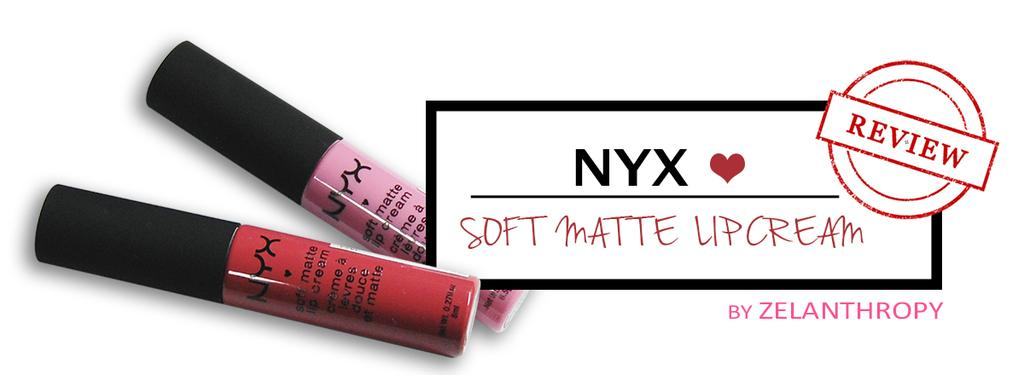What type of cosmetic product can be seen in the image? There are lipsticks in the image. What else is present in the image besides the lipsticks? There is some information in the image. What color is the background of the image? The background of the image is white. What type of cake is being served by the governor in the image? There is no governor or cake present in the image. What kind of paste is used to create the lipsticks in the image? The image does not provide information about the ingredients or materials used to create the lipsticks. 